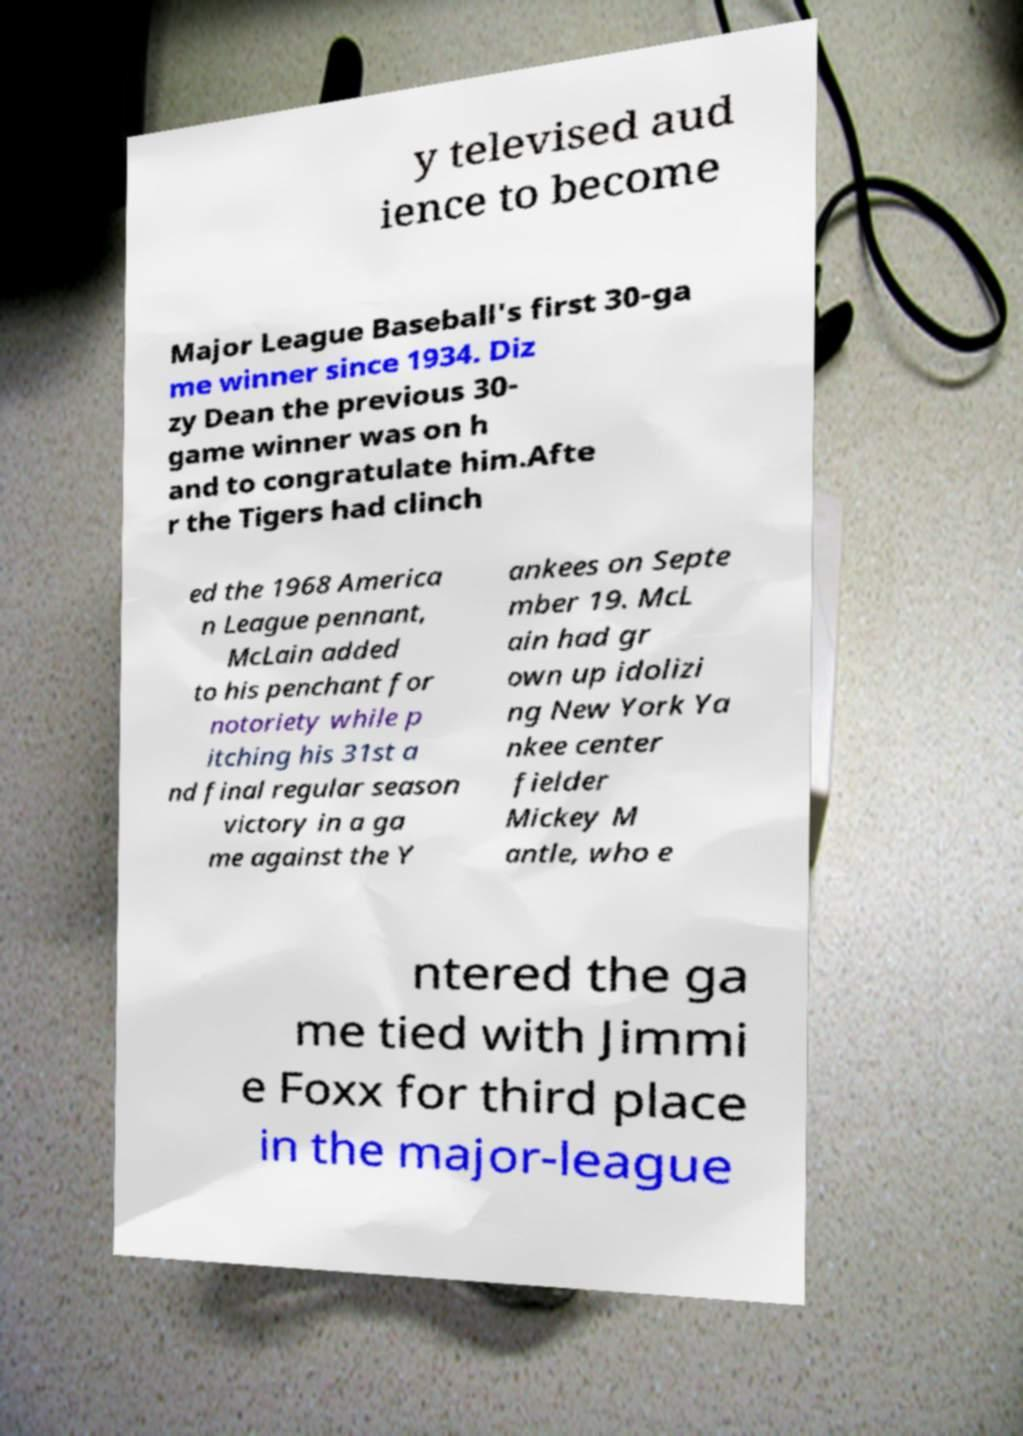There's text embedded in this image that I need extracted. Can you transcribe it verbatim? y televised aud ience to become Major League Baseball's first 30-ga me winner since 1934. Diz zy Dean the previous 30- game winner was on h and to congratulate him.Afte r the Tigers had clinch ed the 1968 America n League pennant, McLain added to his penchant for notoriety while p itching his 31st a nd final regular season victory in a ga me against the Y ankees on Septe mber 19. McL ain had gr own up idolizi ng New York Ya nkee center fielder Mickey M antle, who e ntered the ga me tied with Jimmi e Foxx for third place in the major-league 